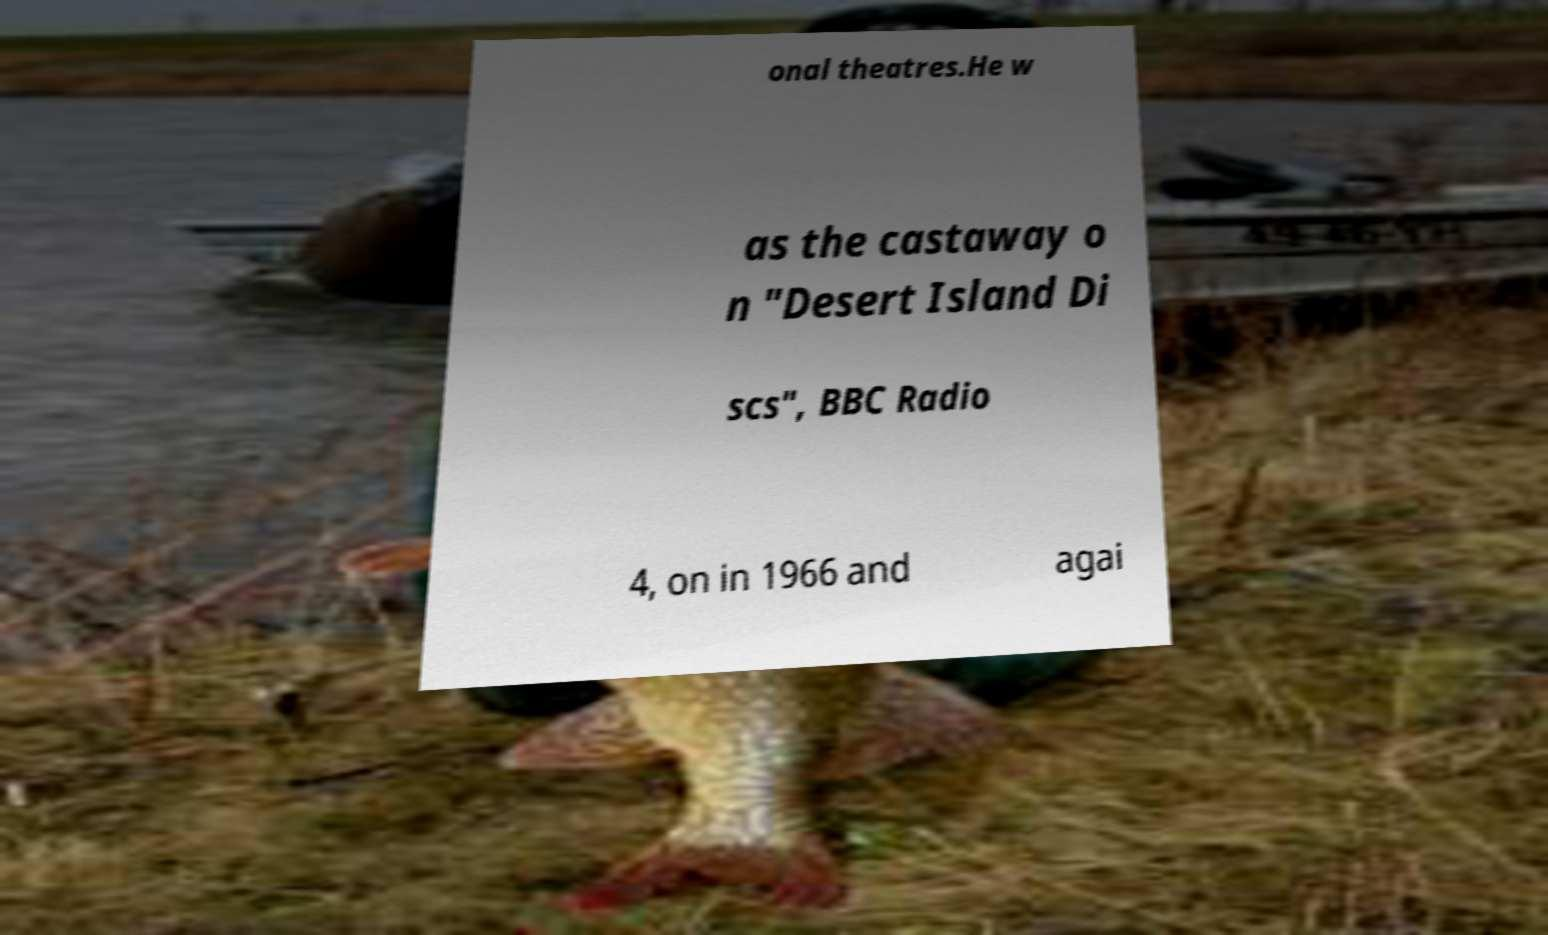There's text embedded in this image that I need extracted. Can you transcribe it verbatim? onal theatres.He w as the castaway o n "Desert Island Di scs", BBC Radio 4, on in 1966 and agai 